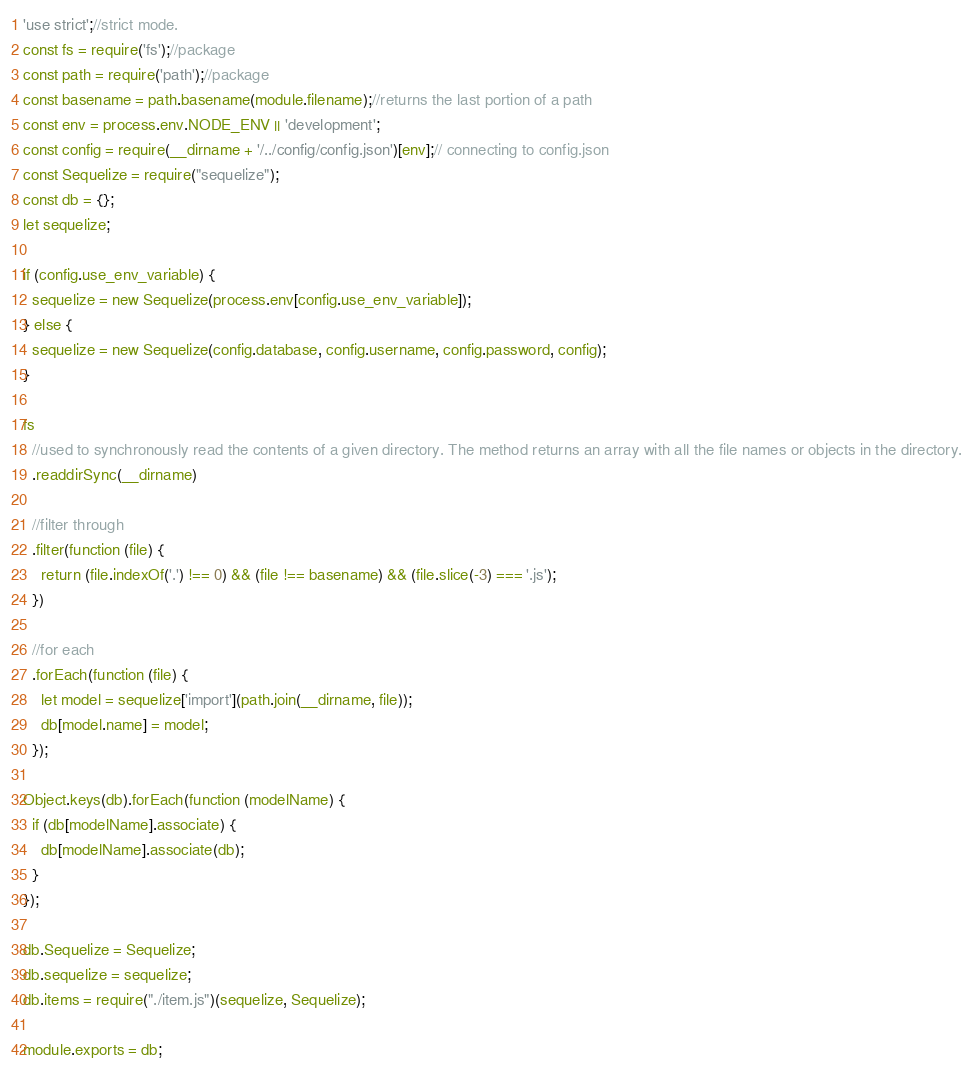Convert code to text. <code><loc_0><loc_0><loc_500><loc_500><_JavaScript_>'use strict';//strict mode. 
const fs = require('fs');//package
const path = require('path');//package
const basename = path.basename(module.filename);//returns the last portion of a path
const env = process.env.NODE_ENV || 'development';
const config = require(__dirname + '/../config/config.json')[env];// connecting to config.json
const Sequelize = require("sequelize");
const db = {};
let sequelize;

if (config.use_env_variable) {
  sequelize = new Sequelize(process.env[config.use_env_variable]);
} else {
  sequelize = new Sequelize(config.database, config.username, config.password, config);
}

fs
  //used to synchronously read the contents of a given directory. The method returns an array with all the file names or objects in the directory.
  .readdirSync(__dirname)

  //filter through 
  .filter(function (file) {
    return (file.indexOf('.') !== 0) && (file !== basename) && (file.slice(-3) === '.js');
  })

  //for each 
  .forEach(function (file) {
    let model = sequelize['import'](path.join(__dirname, file));
    db[model.name] = model;
  });

Object.keys(db).forEach(function (modelName) {
  if (db[modelName].associate) {
    db[modelName].associate(db);
  }
});

db.Sequelize = Sequelize;
db.sequelize = sequelize;
db.items = require("./item.js")(sequelize, Sequelize);

module.exports = db;</code> 